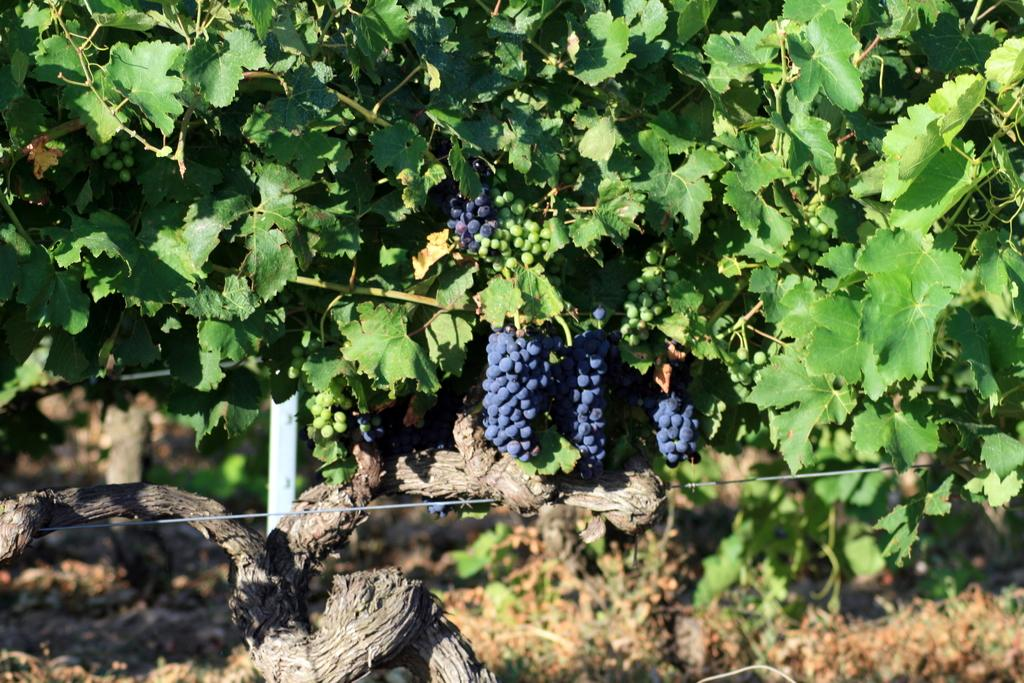What type of tree is in the picture? There is a grape tree in the picture. How many types of grapes are on the tree? There are two types of grapes on the tree. Can you describe the background of the tree? The background of the tree is blurred. How many legs can be seen on the snails in the picture? There are no snails present in the picture, so it is not possible to determine the number of legs on any snails. 